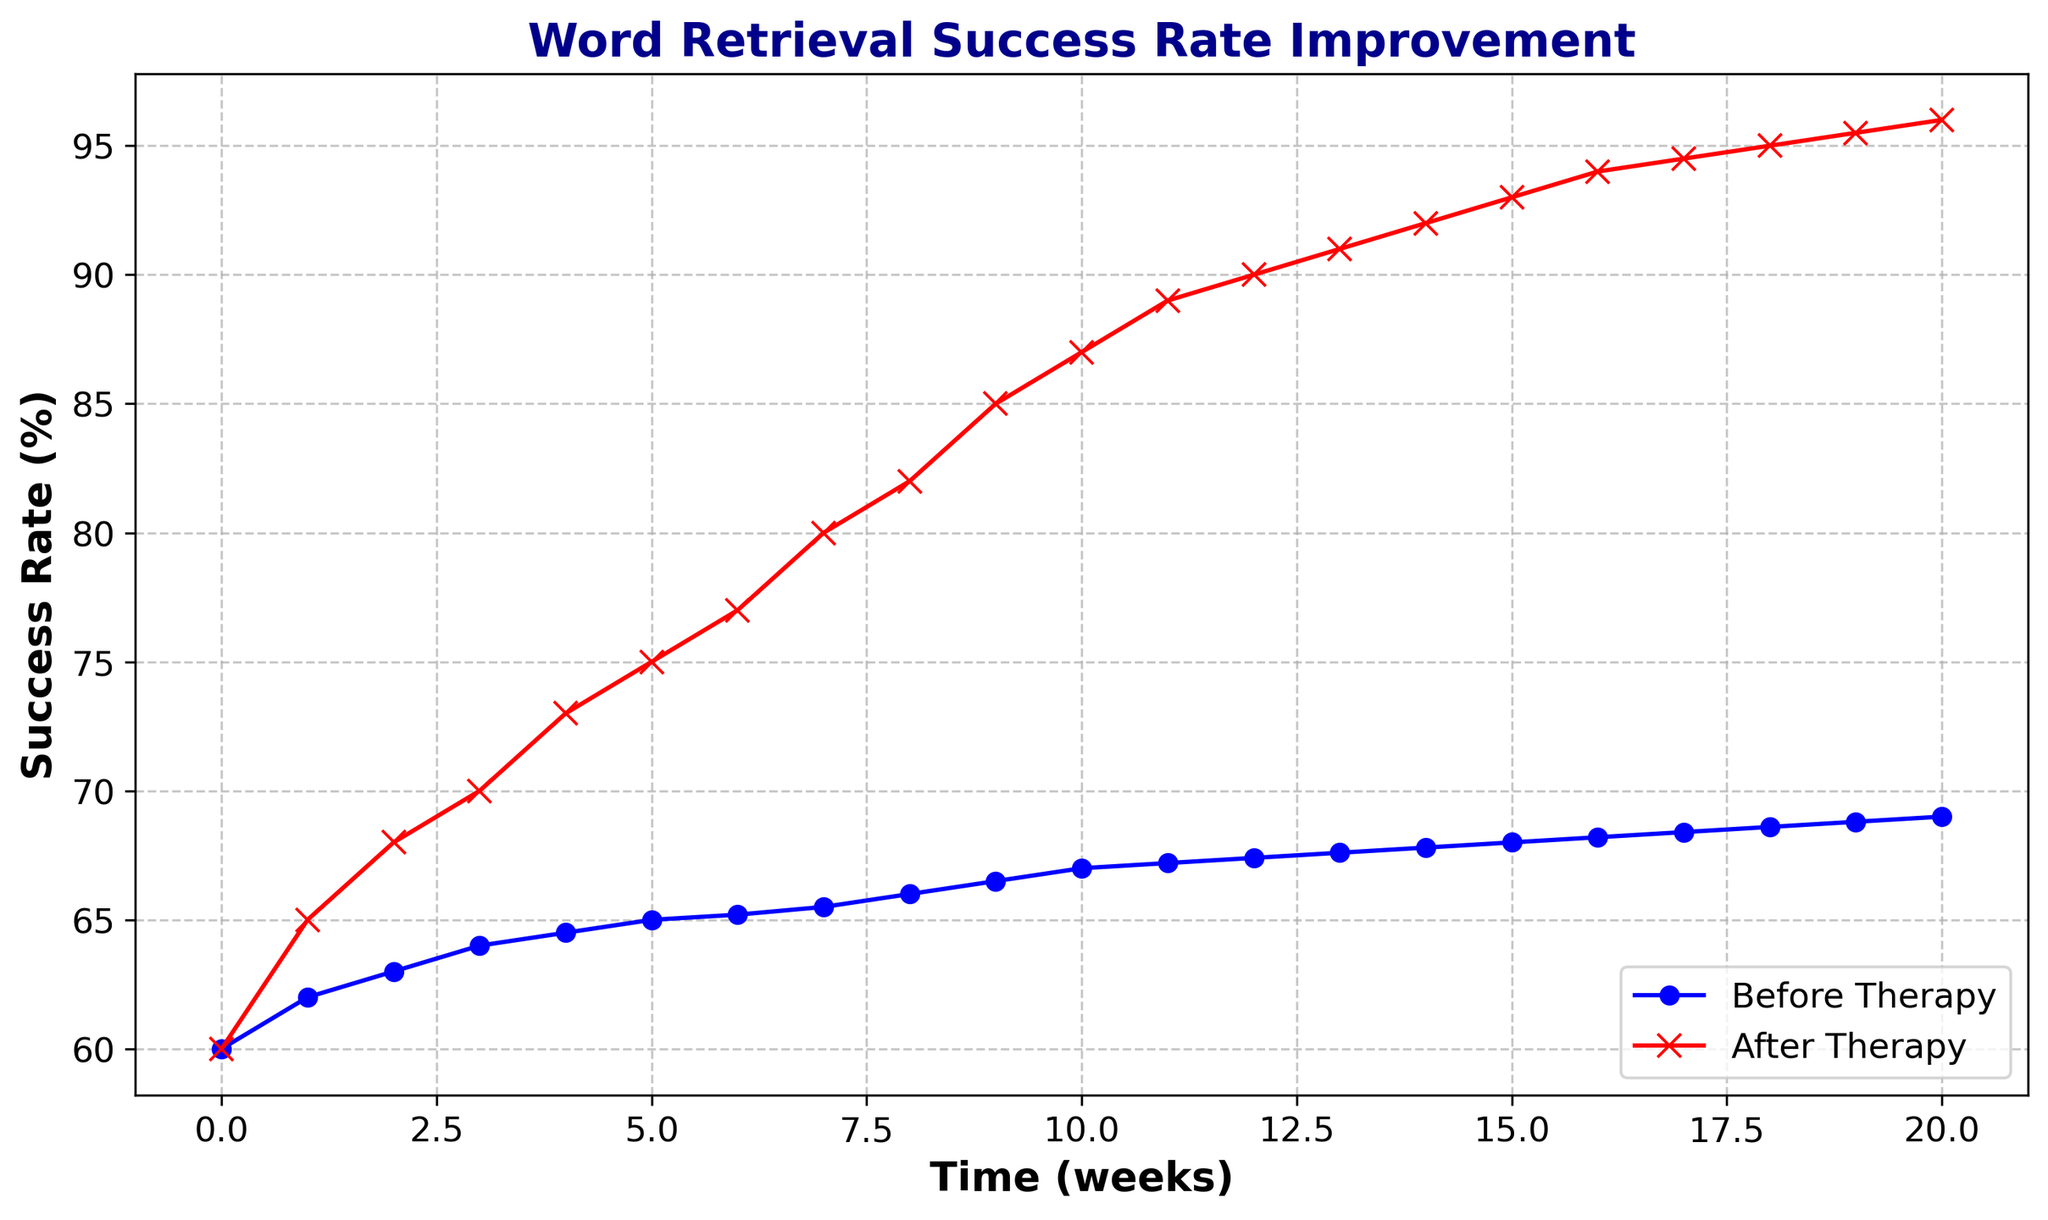How does the success rate before therapy compare to after therapy at the 10-week mark? At the 10-week mark, the success rate before therapy is 67%, while after therapy it is 87%. Comparing these two values directly, we see that the success rate after therapy is 20 percentage points higher than before therapy.
Answer: The success rate after therapy is 20% higher What is the overall trend in the success rate before therapy over the 20-week period? Observing the figure, the success rate before therapy starts at 60% and gradually increases to 69%. This shows a consistent but slow upward trend.
Answer: It shows a consistent but slow upward trend Between which weeks do we see the most significant improvement in success rate after therapy? By examining the plot, from week 0 to week 5, the success rate after therapy increases from 60% to 75%. A significant jump of 15 percentage points in the first 5 weeks is the most notable improvement.
Answer: Weeks 0 to 5 What is the difference in success rate improvement between the 8th and 12th week after therapy? The success rate after therapy at the 8th week is 82% and at the 12th week, it is 90%. The difference is calculated by subtracting 82% from 90%, which gives 8 percentage points.
Answer: 8% How much does the success rate after therapy improve over the entire 20-week period? Initially, the success rate after therapy is 60%, and at the end of the 20-week period, it reaches 96%. The total improvement is calculated by subtracting 60% from 96%, resulting in a 36 percentage point increase.
Answer: 36% Which line has a steeper slope, indicating a faster improvement in success rate: before or after therapy? By comparing the slopes of the two lines, the line representing after therapy has a much steeper slope than the one before therapy. This indicates a faster improvement in success rate after therapy.
Answer: After therapy At which week do the success rate improvements before and after therapy start to diverge significantly? Around the 3rd to 5th week, the success rate improvements for both before and after therapy start to diverge significantly. After therapy, there’s a noticeable jump in success rates that isn't present before therapy.
Answer: Between the 3rd and 5th week Given the same 5-week period, which scenario shows higher consistency in improvement: before or after therapy? Observing the plot for the initial 5-week period, success rate before therapy shows a much gentler and consistent rise compared to the more variable and steeper rise after therapy.
Answer: Before therapy What is the average success rate before and after therapy over the 20-week period? To find the average success rates over 20 weeks, sum the success rates and divide by 20. Before therapy: (60+62+63+64+64.5+65+65.2+65.5+66+66.5+67+67.2+67.4+67.6+67.8+68+68.2+68.4+68.6+68.8+69)/20 = 65.7%. After therapy: (60+65+68+70+73+75+77+80+82+85+87+89+90+91+92+93+94+94.5+95+95.5+96)/20 = 82.6%.
Answer: Before: 65.7%, After: 82.6% What is the success rate before and after therapy at the 15-week mark? The success rate at the 15-week mark before therapy is 68%, whereas after therapy it is 93%.
Answer: Before: 68%, After: 93% 